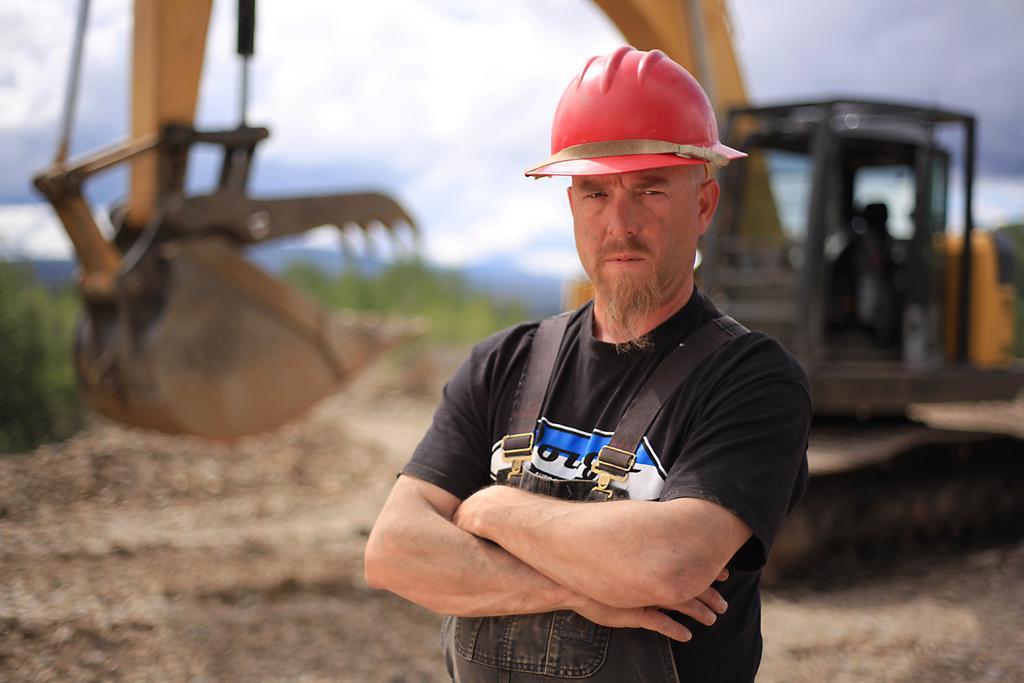In one or two sentences, can you explain what this image depicts? In this image we can see there is a person standing. And at the back there is a crane on the ground and trees and the sky. 